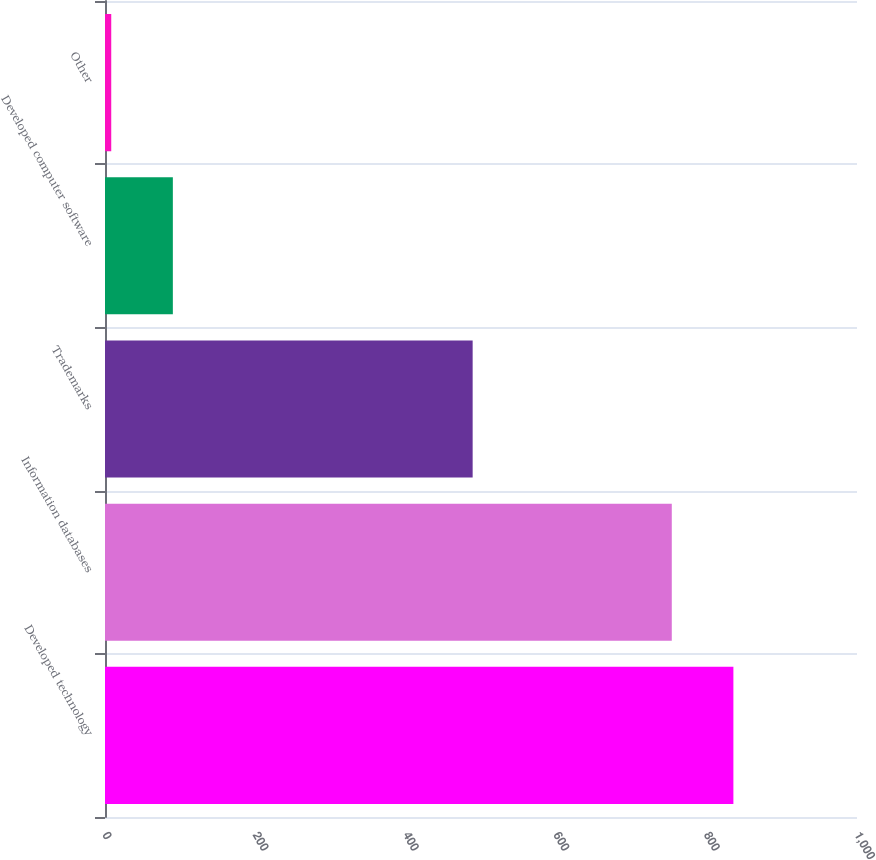<chart> <loc_0><loc_0><loc_500><loc_500><bar_chart><fcel>Developed technology<fcel>Information databases<fcel>Trademarks<fcel>Developed computer software<fcel>Other<nl><fcel>835.63<fcel>753.7<fcel>488.9<fcel>90.23<fcel>8.3<nl></chart> 